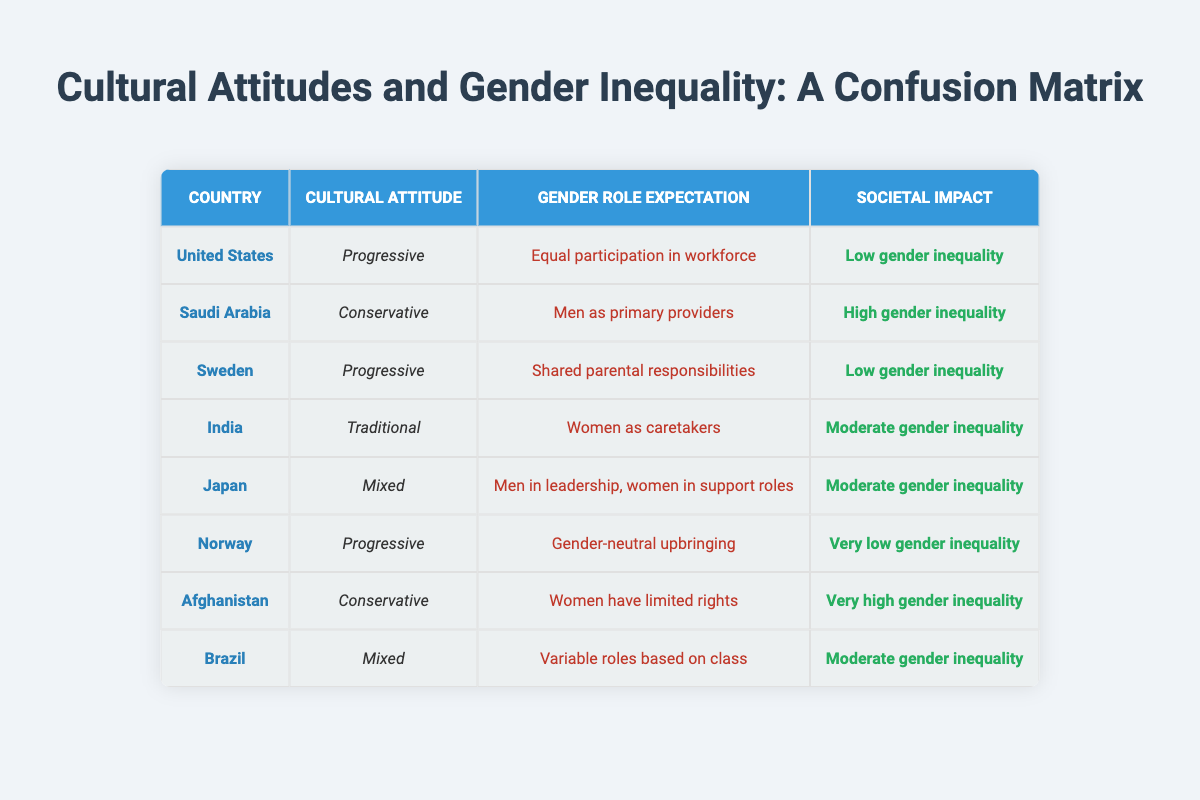What cultural attitude corresponds to very high gender inequality? The table indicates that Afghanistan has a cultural attitude that is Conservative, which corresponds with a societal impact of very high gender inequality.
Answer: Conservative How many countries exhibit low gender inequality according to the table? Both the United States and Sweden show low gender inequality, totaling two countries.
Answer: 2 Is the societal impact in Japan classified as high gender inequality? No, the societal impact in Japan is classified as moderate gender inequality, not high.
Answer: No Which country has the expectation of shared parental responsibilities? Sweden is listed with the expectation of shared parental responsibilities under its gender role expectation.
Answer: Sweden What is the average societal impact level among the countries listed? The countries can be categorized as follows: Very Low (1), Low (2), Moderate (3), High (2), and Very High (1). Counting them gives a total score of 9. Dividing by the number of countries (8) results in an average impact level of moderately low, around the midpoint of the existing categories.
Answer: Moderate How does the societal impact of conservative cultural attitudes compare to progressive ones? The societal impact of conservative attitudes in Saudi Arabia and Afghanistan shows high to very high gender inequality, while progressive attitudes in the United States, Sweden, and Norway show low or very low gender inequality. This indicates a clear contrast in gender inequality levels based on cultural attitudes.
Answer: Conservative attitudes lead to higher gender inequality, while progressive ones lead to lower Which country demonstrates a mixed cultural attitude with a moderate gender inequality level? Brazil exhibits a mixed cultural attitude with the gender role expectation of variable roles based on class, corresponding to moderate gender inequality.
Answer: Brazil What societal impact do countries with progressive cultural attitudes generally have? Countries with progressive cultural attitudes, like the United States, Sweden, and Norway, generally exhibit low or very low gender inequality.
Answer: Low or very low gender inequality Which country has traditional gender role expectations, and what is its societal impact? India is noted for having traditional gender role expectations where women are seen as caretakers, leading to a moderate gender inequality societal impact.
Answer: India 